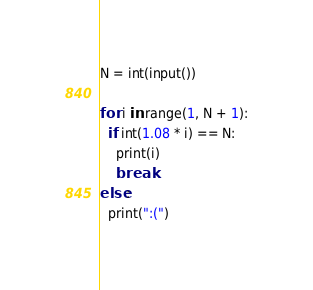<code> <loc_0><loc_0><loc_500><loc_500><_Python_>N = int(input())

for i in range(1, N + 1):
  if int(1.08 * i) == N:
    print(i)
    break
else:
  print(":(")
</code> 